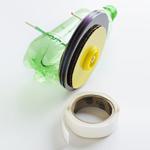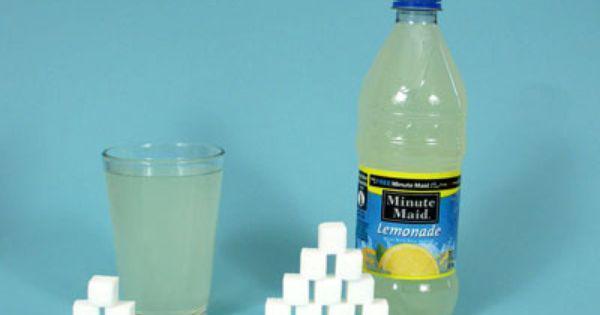The first image is the image on the left, the second image is the image on the right. Analyze the images presented: Is the assertion "At least one container in the image on the right is destroyed." valid? Answer yes or no. No. The first image is the image on the left, the second image is the image on the right. Assess this claim about the two images: "All bottles in the pair are green.". Correct or not? Answer yes or no. No. 